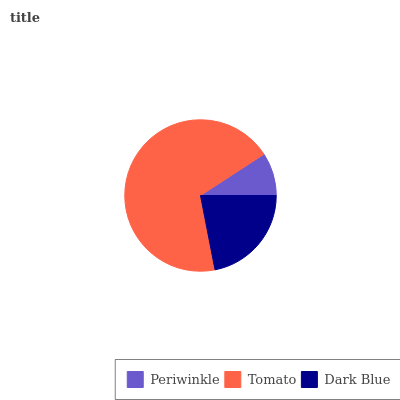Is Periwinkle the minimum?
Answer yes or no. Yes. Is Tomato the maximum?
Answer yes or no. Yes. Is Dark Blue the minimum?
Answer yes or no. No. Is Dark Blue the maximum?
Answer yes or no. No. Is Tomato greater than Dark Blue?
Answer yes or no. Yes. Is Dark Blue less than Tomato?
Answer yes or no. Yes. Is Dark Blue greater than Tomato?
Answer yes or no. No. Is Tomato less than Dark Blue?
Answer yes or no. No. Is Dark Blue the high median?
Answer yes or no. Yes. Is Dark Blue the low median?
Answer yes or no. Yes. Is Periwinkle the high median?
Answer yes or no. No. Is Periwinkle the low median?
Answer yes or no. No. 